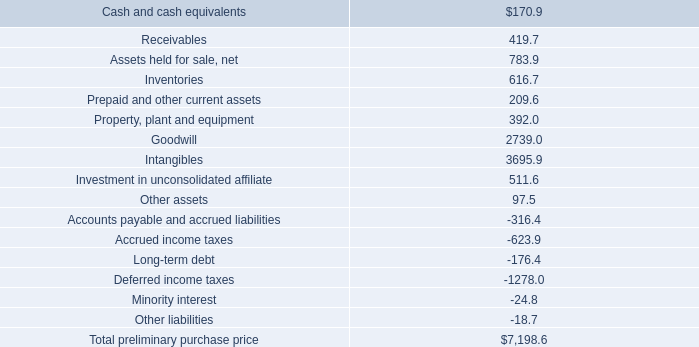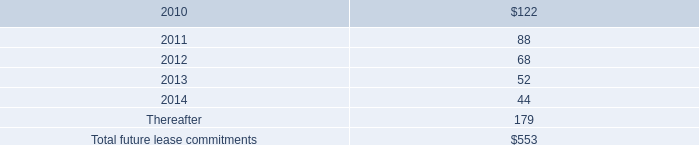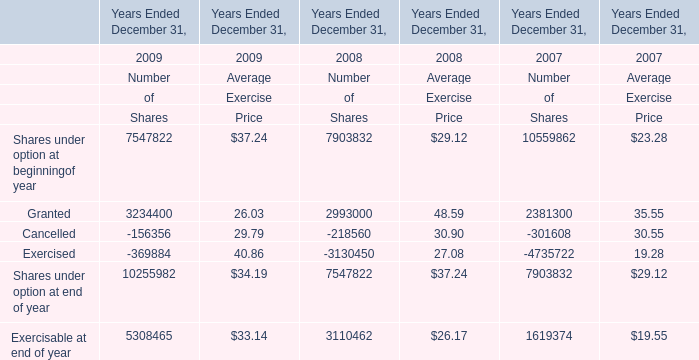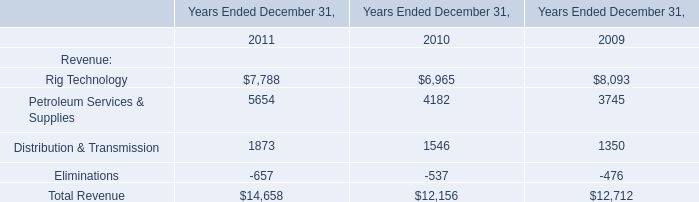What's the current growth rate of Number of Shares for Shares under option at end of year Ended December 31? 
Computations: ((10255982 - 7547822) / 7547822)
Answer: 0.3588. 